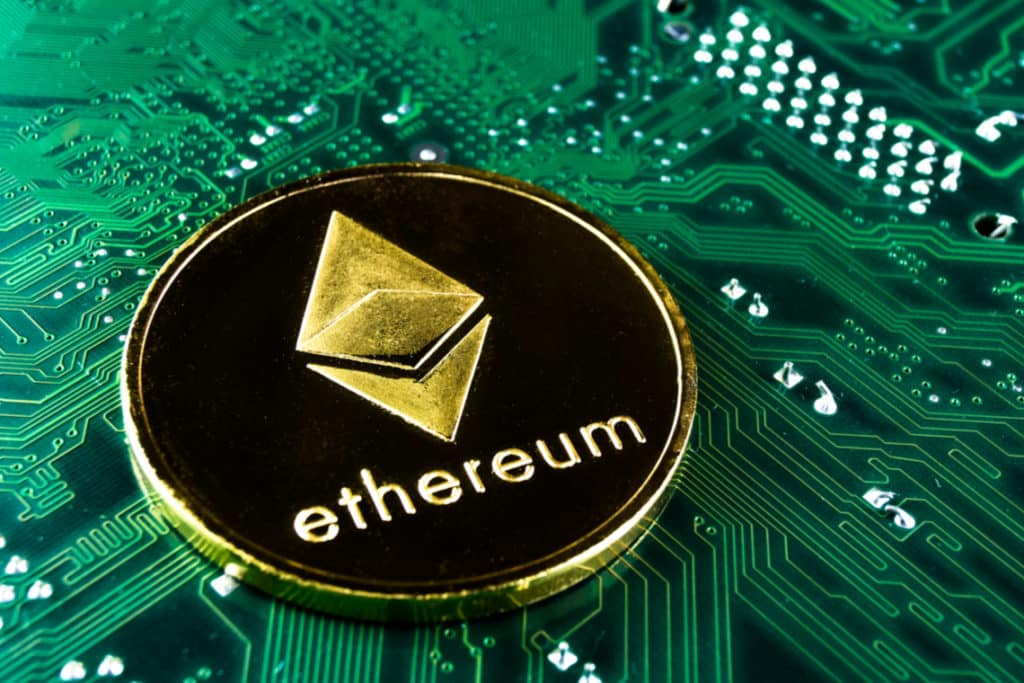Imagine a futuristic world where the depicted relationship has evolved. What does it look like? In a futuristic world where the relationship between Ethereum and the underlying technology has evolved dramatically, we might envision an environment where blockchain technology and advanced hardware are seamlessly integrated into daily life. Imagine homes and cities powered by decentralized energy systems that are monitored and managed through blockchain, ensuring transparent and efficient use of resources. Autonomous vehicles using blockchain for secure, verifiable communication navigate effortlessly. Personal devices not only serve computational tasks but also participate in a decentralized network, contributing spare processing power to global blockchain networks. Hardware becomes highly specialized, with quantum computing making blockchain operations exponentially faster and more secure. This deeply interconnected world leverages blockchain to enhance security, transparency, and efficiency in all facets of life. 